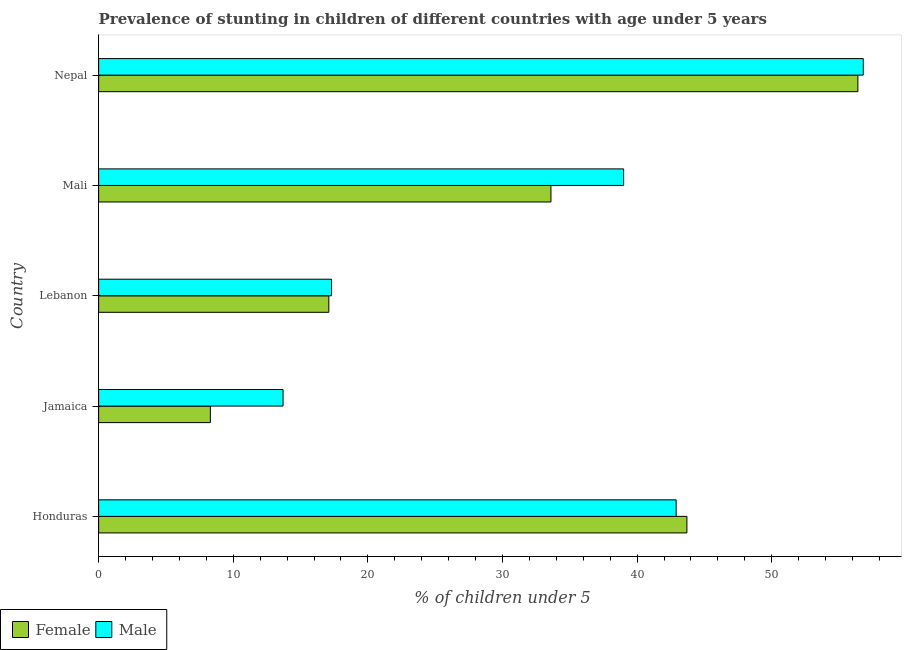How many different coloured bars are there?
Your answer should be compact. 2. How many groups of bars are there?
Provide a succinct answer. 5. Are the number of bars per tick equal to the number of legend labels?
Give a very brief answer. Yes. Are the number of bars on each tick of the Y-axis equal?
Your answer should be compact. Yes. How many bars are there on the 5th tick from the bottom?
Offer a very short reply. 2. What is the label of the 2nd group of bars from the top?
Your answer should be very brief. Mali. What is the percentage of stunted female children in Jamaica?
Your answer should be very brief. 8.3. Across all countries, what is the maximum percentage of stunted female children?
Offer a very short reply. 56.4. Across all countries, what is the minimum percentage of stunted male children?
Keep it short and to the point. 13.7. In which country was the percentage of stunted female children maximum?
Make the answer very short. Nepal. In which country was the percentage of stunted male children minimum?
Your response must be concise. Jamaica. What is the total percentage of stunted male children in the graph?
Your answer should be compact. 169.7. What is the difference between the percentage of stunted male children in Honduras and that in Lebanon?
Give a very brief answer. 25.6. What is the difference between the percentage of stunted female children in Honduras and the percentage of stunted male children in Nepal?
Make the answer very short. -13.1. What is the average percentage of stunted female children per country?
Offer a very short reply. 31.82. What is the difference between the percentage of stunted female children and percentage of stunted male children in Nepal?
Make the answer very short. -0.4. In how many countries, is the percentage of stunted male children greater than 50 %?
Your answer should be compact. 1. Is the percentage of stunted female children in Lebanon less than that in Mali?
Provide a short and direct response. Yes. What is the difference between the highest and the second highest percentage of stunted male children?
Offer a terse response. 13.9. What is the difference between the highest and the lowest percentage of stunted male children?
Provide a short and direct response. 43.1. In how many countries, is the percentage of stunted male children greater than the average percentage of stunted male children taken over all countries?
Keep it short and to the point. 3. Is the sum of the percentage of stunted male children in Jamaica and Nepal greater than the maximum percentage of stunted female children across all countries?
Offer a terse response. Yes. What does the 1st bar from the top in Honduras represents?
Make the answer very short. Male. How many bars are there?
Your answer should be compact. 10. Are all the bars in the graph horizontal?
Make the answer very short. Yes. How many countries are there in the graph?
Your answer should be very brief. 5. Are the values on the major ticks of X-axis written in scientific E-notation?
Your answer should be very brief. No. Where does the legend appear in the graph?
Ensure brevity in your answer.  Bottom left. How many legend labels are there?
Offer a very short reply. 2. How are the legend labels stacked?
Offer a terse response. Horizontal. What is the title of the graph?
Provide a short and direct response. Prevalence of stunting in children of different countries with age under 5 years. Does "Methane" appear as one of the legend labels in the graph?
Your answer should be very brief. No. What is the label or title of the X-axis?
Give a very brief answer.  % of children under 5. What is the  % of children under 5 of Female in Honduras?
Offer a terse response. 43.7. What is the  % of children under 5 in Male in Honduras?
Offer a very short reply. 42.9. What is the  % of children under 5 in Female in Jamaica?
Your answer should be very brief. 8.3. What is the  % of children under 5 in Male in Jamaica?
Offer a terse response. 13.7. What is the  % of children under 5 of Female in Lebanon?
Your answer should be very brief. 17.1. What is the  % of children under 5 of Male in Lebanon?
Ensure brevity in your answer.  17.3. What is the  % of children under 5 in Female in Mali?
Your answer should be very brief. 33.6. What is the  % of children under 5 in Female in Nepal?
Make the answer very short. 56.4. What is the  % of children under 5 of Male in Nepal?
Your answer should be compact. 56.8. Across all countries, what is the maximum  % of children under 5 in Female?
Your answer should be very brief. 56.4. Across all countries, what is the maximum  % of children under 5 of Male?
Provide a short and direct response. 56.8. Across all countries, what is the minimum  % of children under 5 in Female?
Your response must be concise. 8.3. Across all countries, what is the minimum  % of children under 5 in Male?
Offer a very short reply. 13.7. What is the total  % of children under 5 of Female in the graph?
Keep it short and to the point. 159.1. What is the total  % of children under 5 of Male in the graph?
Provide a short and direct response. 169.7. What is the difference between the  % of children under 5 of Female in Honduras and that in Jamaica?
Your response must be concise. 35.4. What is the difference between the  % of children under 5 in Male in Honduras and that in Jamaica?
Offer a very short reply. 29.2. What is the difference between the  % of children under 5 in Female in Honduras and that in Lebanon?
Give a very brief answer. 26.6. What is the difference between the  % of children under 5 in Male in Honduras and that in Lebanon?
Make the answer very short. 25.6. What is the difference between the  % of children under 5 of Male in Honduras and that in Nepal?
Your response must be concise. -13.9. What is the difference between the  % of children under 5 in Male in Jamaica and that in Lebanon?
Give a very brief answer. -3.6. What is the difference between the  % of children under 5 in Female in Jamaica and that in Mali?
Your answer should be compact. -25.3. What is the difference between the  % of children under 5 of Male in Jamaica and that in Mali?
Ensure brevity in your answer.  -25.3. What is the difference between the  % of children under 5 of Female in Jamaica and that in Nepal?
Keep it short and to the point. -48.1. What is the difference between the  % of children under 5 of Male in Jamaica and that in Nepal?
Ensure brevity in your answer.  -43.1. What is the difference between the  % of children under 5 of Female in Lebanon and that in Mali?
Your answer should be very brief. -16.5. What is the difference between the  % of children under 5 in Male in Lebanon and that in Mali?
Your answer should be compact. -21.7. What is the difference between the  % of children under 5 of Female in Lebanon and that in Nepal?
Your response must be concise. -39.3. What is the difference between the  % of children under 5 in Male in Lebanon and that in Nepal?
Provide a succinct answer. -39.5. What is the difference between the  % of children under 5 in Female in Mali and that in Nepal?
Your response must be concise. -22.8. What is the difference between the  % of children under 5 of Male in Mali and that in Nepal?
Your answer should be compact. -17.8. What is the difference between the  % of children under 5 in Female in Honduras and the  % of children under 5 in Male in Jamaica?
Your answer should be very brief. 30. What is the difference between the  % of children under 5 in Female in Honduras and the  % of children under 5 in Male in Lebanon?
Offer a very short reply. 26.4. What is the difference between the  % of children under 5 in Female in Honduras and the  % of children under 5 in Male in Mali?
Offer a terse response. 4.7. What is the difference between the  % of children under 5 of Female in Honduras and the  % of children under 5 of Male in Nepal?
Provide a short and direct response. -13.1. What is the difference between the  % of children under 5 in Female in Jamaica and the  % of children under 5 in Male in Lebanon?
Your answer should be compact. -9. What is the difference between the  % of children under 5 in Female in Jamaica and the  % of children under 5 in Male in Mali?
Offer a very short reply. -30.7. What is the difference between the  % of children under 5 in Female in Jamaica and the  % of children under 5 in Male in Nepal?
Ensure brevity in your answer.  -48.5. What is the difference between the  % of children under 5 in Female in Lebanon and the  % of children under 5 in Male in Mali?
Offer a terse response. -21.9. What is the difference between the  % of children under 5 in Female in Lebanon and the  % of children under 5 in Male in Nepal?
Your response must be concise. -39.7. What is the difference between the  % of children under 5 in Female in Mali and the  % of children under 5 in Male in Nepal?
Ensure brevity in your answer.  -23.2. What is the average  % of children under 5 in Female per country?
Your answer should be compact. 31.82. What is the average  % of children under 5 in Male per country?
Ensure brevity in your answer.  33.94. What is the difference between the  % of children under 5 of Female and  % of children under 5 of Male in Honduras?
Give a very brief answer. 0.8. What is the difference between the  % of children under 5 of Female and  % of children under 5 of Male in Mali?
Your answer should be compact. -5.4. What is the ratio of the  % of children under 5 in Female in Honduras to that in Jamaica?
Keep it short and to the point. 5.27. What is the ratio of the  % of children under 5 of Male in Honduras to that in Jamaica?
Offer a terse response. 3.13. What is the ratio of the  % of children under 5 in Female in Honduras to that in Lebanon?
Your answer should be very brief. 2.56. What is the ratio of the  % of children under 5 of Male in Honduras to that in Lebanon?
Provide a succinct answer. 2.48. What is the ratio of the  % of children under 5 of Female in Honduras to that in Mali?
Make the answer very short. 1.3. What is the ratio of the  % of children under 5 of Male in Honduras to that in Mali?
Offer a terse response. 1.1. What is the ratio of the  % of children under 5 in Female in Honduras to that in Nepal?
Provide a succinct answer. 0.77. What is the ratio of the  % of children under 5 in Male in Honduras to that in Nepal?
Your response must be concise. 0.76. What is the ratio of the  % of children under 5 in Female in Jamaica to that in Lebanon?
Your response must be concise. 0.49. What is the ratio of the  % of children under 5 in Male in Jamaica to that in Lebanon?
Give a very brief answer. 0.79. What is the ratio of the  % of children under 5 of Female in Jamaica to that in Mali?
Offer a very short reply. 0.25. What is the ratio of the  % of children under 5 of Male in Jamaica to that in Mali?
Your response must be concise. 0.35. What is the ratio of the  % of children under 5 of Female in Jamaica to that in Nepal?
Your response must be concise. 0.15. What is the ratio of the  % of children under 5 in Male in Jamaica to that in Nepal?
Ensure brevity in your answer.  0.24. What is the ratio of the  % of children under 5 of Female in Lebanon to that in Mali?
Make the answer very short. 0.51. What is the ratio of the  % of children under 5 of Male in Lebanon to that in Mali?
Your answer should be very brief. 0.44. What is the ratio of the  % of children under 5 of Female in Lebanon to that in Nepal?
Keep it short and to the point. 0.3. What is the ratio of the  % of children under 5 of Male in Lebanon to that in Nepal?
Your answer should be compact. 0.3. What is the ratio of the  % of children under 5 of Female in Mali to that in Nepal?
Provide a succinct answer. 0.6. What is the ratio of the  % of children under 5 of Male in Mali to that in Nepal?
Make the answer very short. 0.69. What is the difference between the highest and the second highest  % of children under 5 of Female?
Offer a very short reply. 12.7. What is the difference between the highest and the second highest  % of children under 5 of Male?
Offer a very short reply. 13.9. What is the difference between the highest and the lowest  % of children under 5 in Female?
Your answer should be very brief. 48.1. What is the difference between the highest and the lowest  % of children under 5 of Male?
Provide a short and direct response. 43.1. 